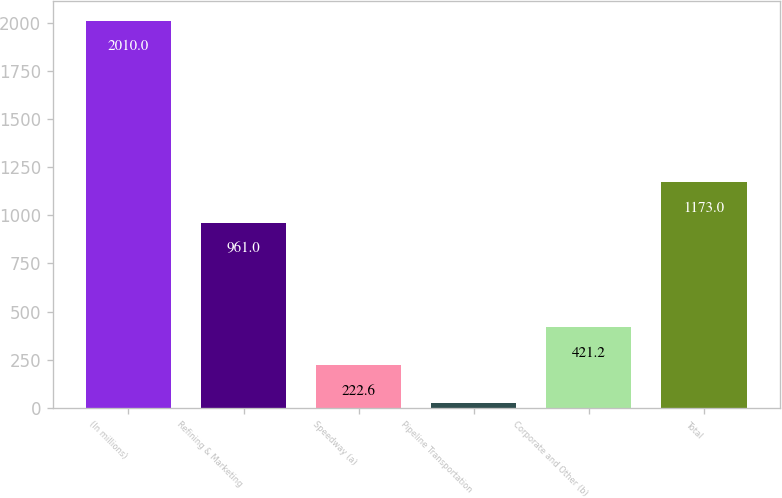Convert chart to OTSL. <chart><loc_0><loc_0><loc_500><loc_500><bar_chart><fcel>(In millions)<fcel>Refining & Marketing<fcel>Speedway (a)<fcel>Pipeline Transportation<fcel>Corporate and Other (b)<fcel>Total<nl><fcel>2010<fcel>961<fcel>222.6<fcel>24<fcel>421.2<fcel>1173<nl></chart> 